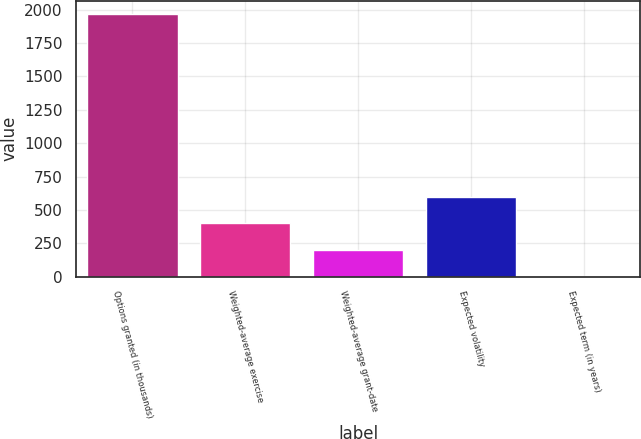Convert chart to OTSL. <chart><loc_0><loc_0><loc_500><loc_500><bar_chart><fcel>Options granted (in thousands)<fcel>Weighted-average exercise<fcel>Weighted-average grant-date<fcel>Expected volatility<fcel>Expected term (in years)<nl><fcel>1969<fcel>398.84<fcel>202.57<fcel>595.11<fcel>6.3<nl></chart> 